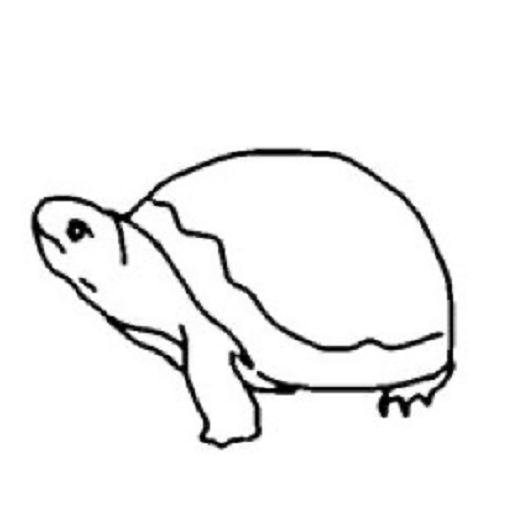Describe this drawing for a Stable Diffusion prompt This image appears to be a simple black and white line drawing of a turtle. The outline depicts the rounded shell, four legs, and a small head of the turtle. The drawing has a minimalistic and schematic style, without any additional details or shading. This could be a suitable prompt for a Stable Diffusion model to generate an image of a turtle with a similar basic, line art-style representation. 